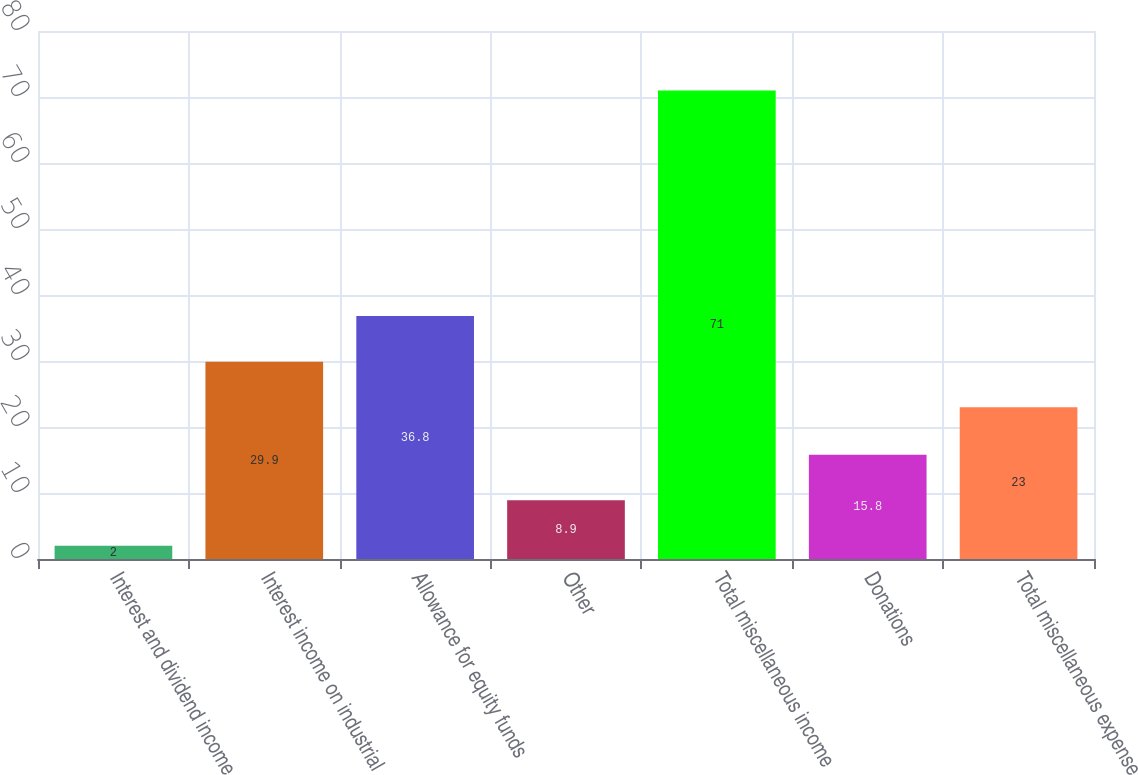<chart> <loc_0><loc_0><loc_500><loc_500><bar_chart><fcel>Interest and dividend income<fcel>Interest income on industrial<fcel>Allowance for equity funds<fcel>Other<fcel>Total miscellaneous income<fcel>Donations<fcel>Total miscellaneous expense<nl><fcel>2<fcel>29.9<fcel>36.8<fcel>8.9<fcel>71<fcel>15.8<fcel>23<nl></chart> 